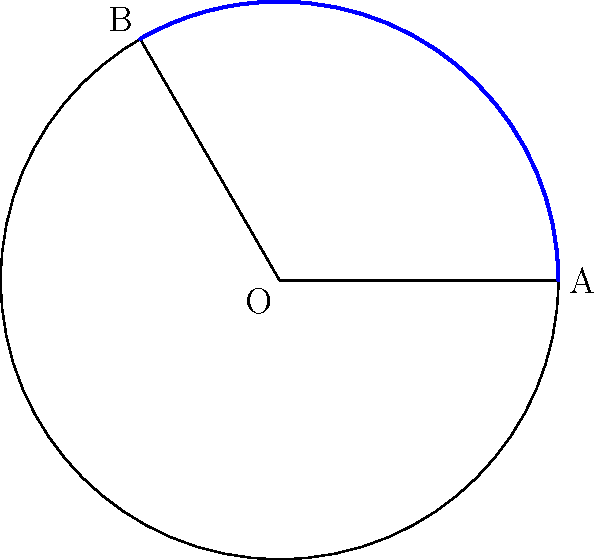In the design of a new avant-garde theatre, the proscenium arch is modeled after a circular arc. If the radius of this circle is 15 meters and the central angle subtended by the arc is 120°, what is the length of the proscenium arch to the nearest meter? Assume pi is approximately 3.14. Let's approach this step-by-step:

1) The formula for arc length is:
   $$s = r\theta$$
   where $s$ is the arc length, $r$ is the radius, and $\theta$ is the central angle in radians.

2) We're given the angle in degrees (120°), but we need it in radians. To convert:
   $$\theta = 120° \times \frac{\pi}{180°} = \frac{2\pi}{3} \approx 2.09$$

3) Now we can plug into our formula:
   $$s = r\theta = 15 \times \frac{2\pi}{3} = 10\pi$$

4) Calculate:
   $$s = 10 \times 3.14 = 31.4$$

5) Rounding to the nearest meter:
   $$s \approx 31 \text{ meters}$$
Answer: 31 meters 